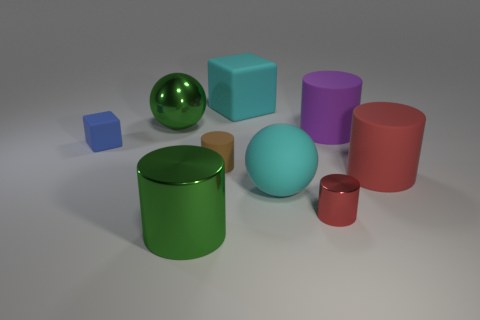There is a cyan ball; does it have the same size as the cylinder in front of the small red thing?
Keep it short and to the point. Yes. There is a large cylinder that is to the left of the cyan ball that is to the left of the metallic object to the right of the big block; what is it made of?
Give a very brief answer. Metal. How many objects are cyan metal cubes or green metal things?
Offer a terse response. 2. There is a matte cylinder that is to the left of the small red shiny cylinder; is it the same color as the small thing on the right side of the big cyan block?
Provide a succinct answer. No. The cyan object that is the same size as the cyan ball is what shape?
Provide a succinct answer. Cube. What number of objects are either big green shiny things behind the brown matte cylinder or small objects on the right side of the green shiny cylinder?
Offer a very short reply. 3. Is the number of blue rubber things less than the number of green rubber cylinders?
Your answer should be compact. No. What is the material of the red object that is the same size as the blue rubber object?
Provide a short and direct response. Metal. There is a green shiny thing that is in front of the red metallic object; does it have the same size as the cyan thing that is right of the big cyan block?
Keep it short and to the point. Yes. Are there any big red balls made of the same material as the big cyan ball?
Ensure brevity in your answer.  No. 